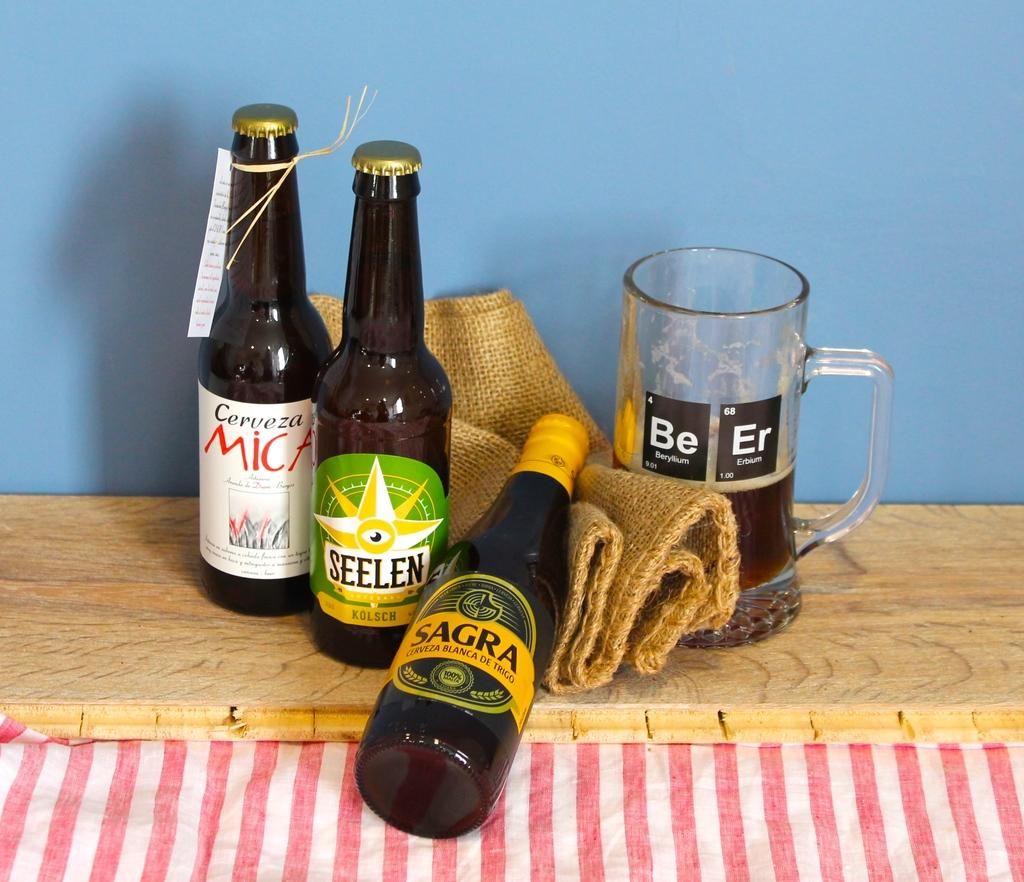<image>
Describe the image concisely. A cup with the elements Beryllium and Erbium on it next to bottles of alcohol. 